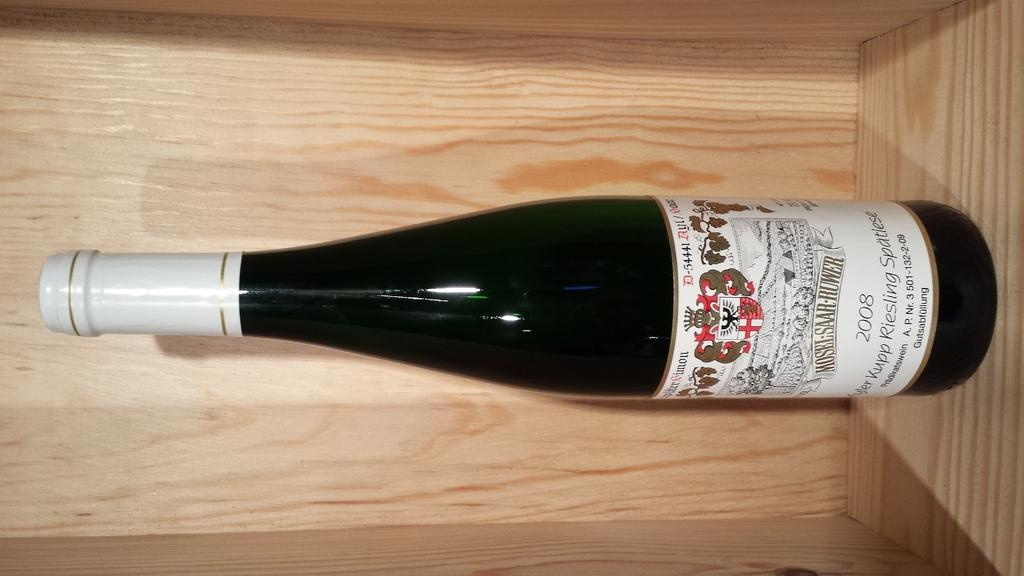<image>
Create a compact narrative representing the image presented. a bottle of wine with D-54441 on the label in a wood case 